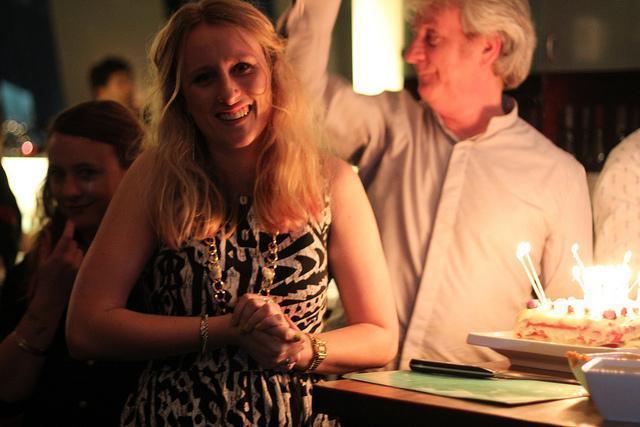How many people are in the photo?
Give a very brief answer. 5. 